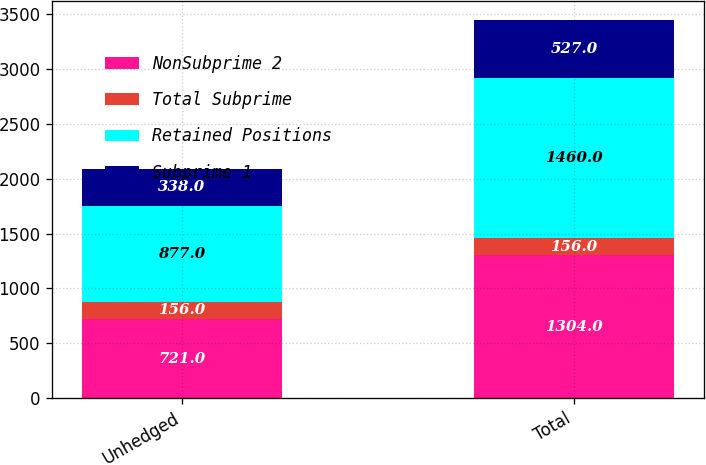Convert chart to OTSL. <chart><loc_0><loc_0><loc_500><loc_500><stacked_bar_chart><ecel><fcel>Unhedged<fcel>Total<nl><fcel>NonSubprime 2<fcel>721<fcel>1304<nl><fcel>Total Subprime<fcel>156<fcel>156<nl><fcel>Retained Positions<fcel>877<fcel>1460<nl><fcel>Subprime 1<fcel>338<fcel>527<nl></chart> 